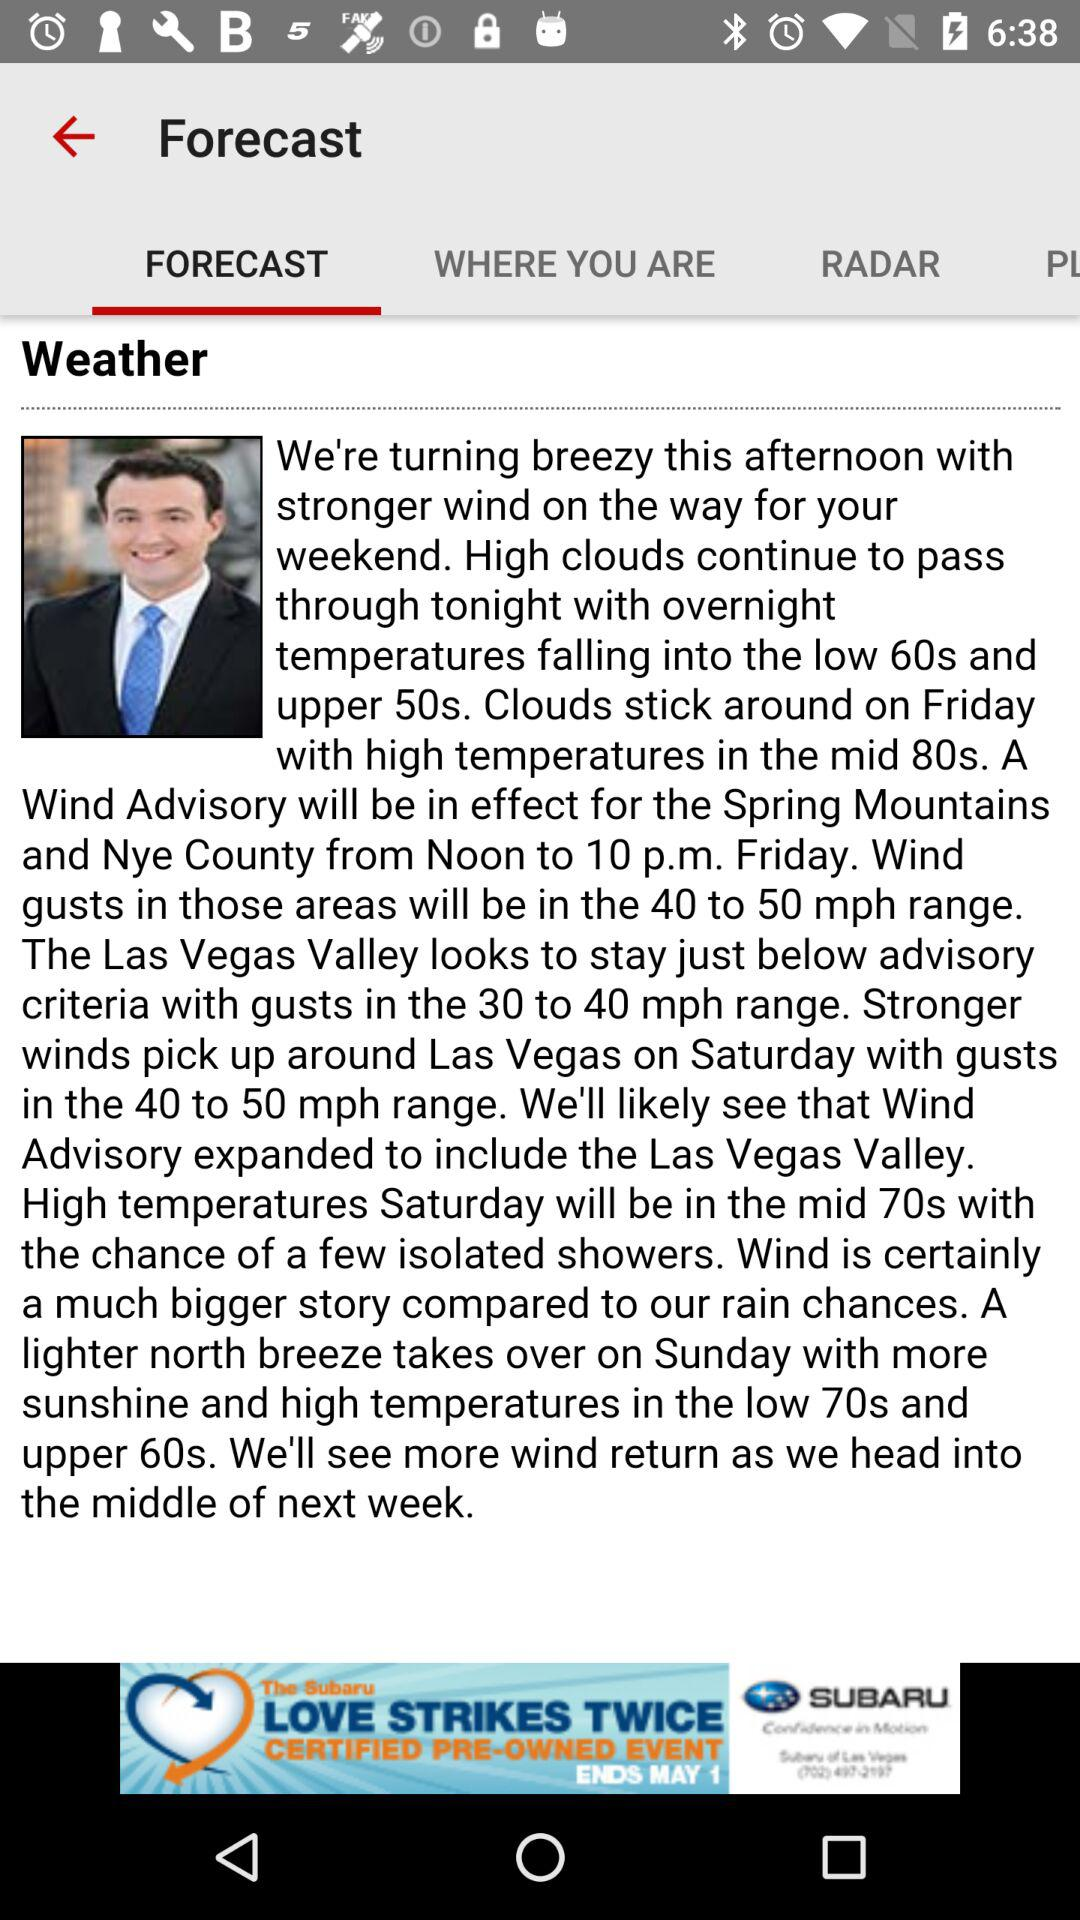What tab is selected? The selected tab is "FORECAST". 